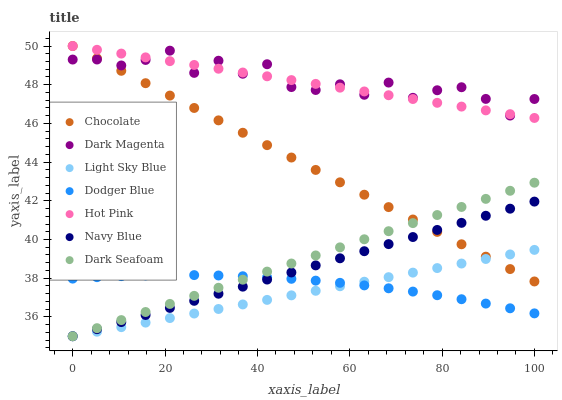Does Light Sky Blue have the minimum area under the curve?
Answer yes or no. Yes. Does Dark Magenta have the maximum area under the curve?
Answer yes or no. Yes. Does Navy Blue have the minimum area under the curve?
Answer yes or no. No. Does Navy Blue have the maximum area under the curve?
Answer yes or no. No. Is Chocolate the smoothest?
Answer yes or no. Yes. Is Dark Magenta the roughest?
Answer yes or no. Yes. Is Navy Blue the smoothest?
Answer yes or no. No. Is Navy Blue the roughest?
Answer yes or no. No. Does Navy Blue have the lowest value?
Answer yes or no. Yes. Does Hot Pink have the lowest value?
Answer yes or no. No. Does Chocolate have the highest value?
Answer yes or no. Yes. Does Navy Blue have the highest value?
Answer yes or no. No. Is Dodger Blue less than Chocolate?
Answer yes or no. Yes. Is Chocolate greater than Dodger Blue?
Answer yes or no. Yes. Does Light Sky Blue intersect Dark Seafoam?
Answer yes or no. Yes. Is Light Sky Blue less than Dark Seafoam?
Answer yes or no. No. Is Light Sky Blue greater than Dark Seafoam?
Answer yes or no. No. Does Dodger Blue intersect Chocolate?
Answer yes or no. No. 